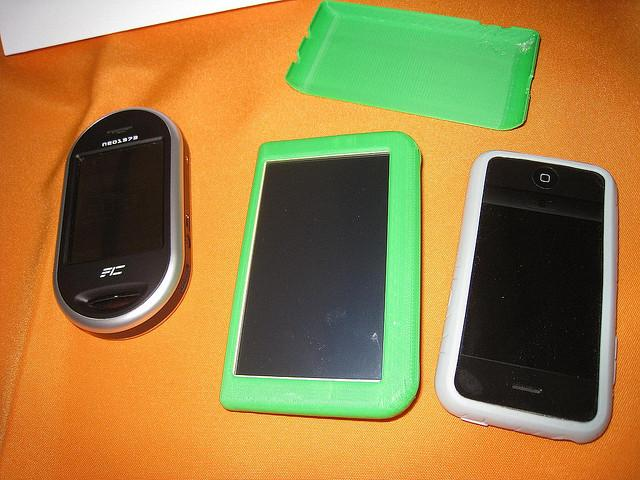What is all the way to the right? Please explain your reasoning. phone. There is a phone. 